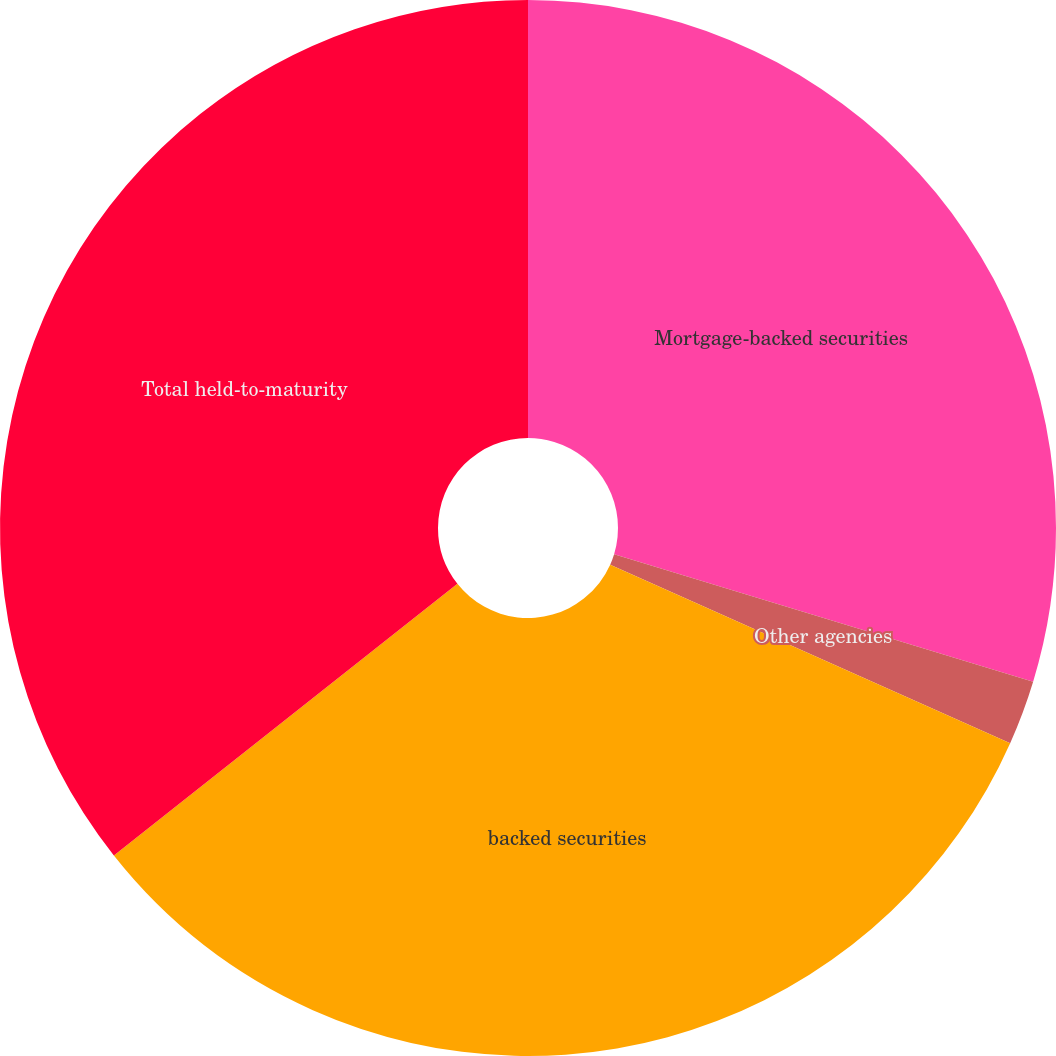Convert chart. <chart><loc_0><loc_0><loc_500><loc_500><pie_chart><fcel>Mortgage-backed securities<fcel>Other agencies<fcel>backed securities<fcel>Total held-to-maturity<nl><fcel>29.7%<fcel>1.98%<fcel>32.67%<fcel>35.65%<nl></chart> 